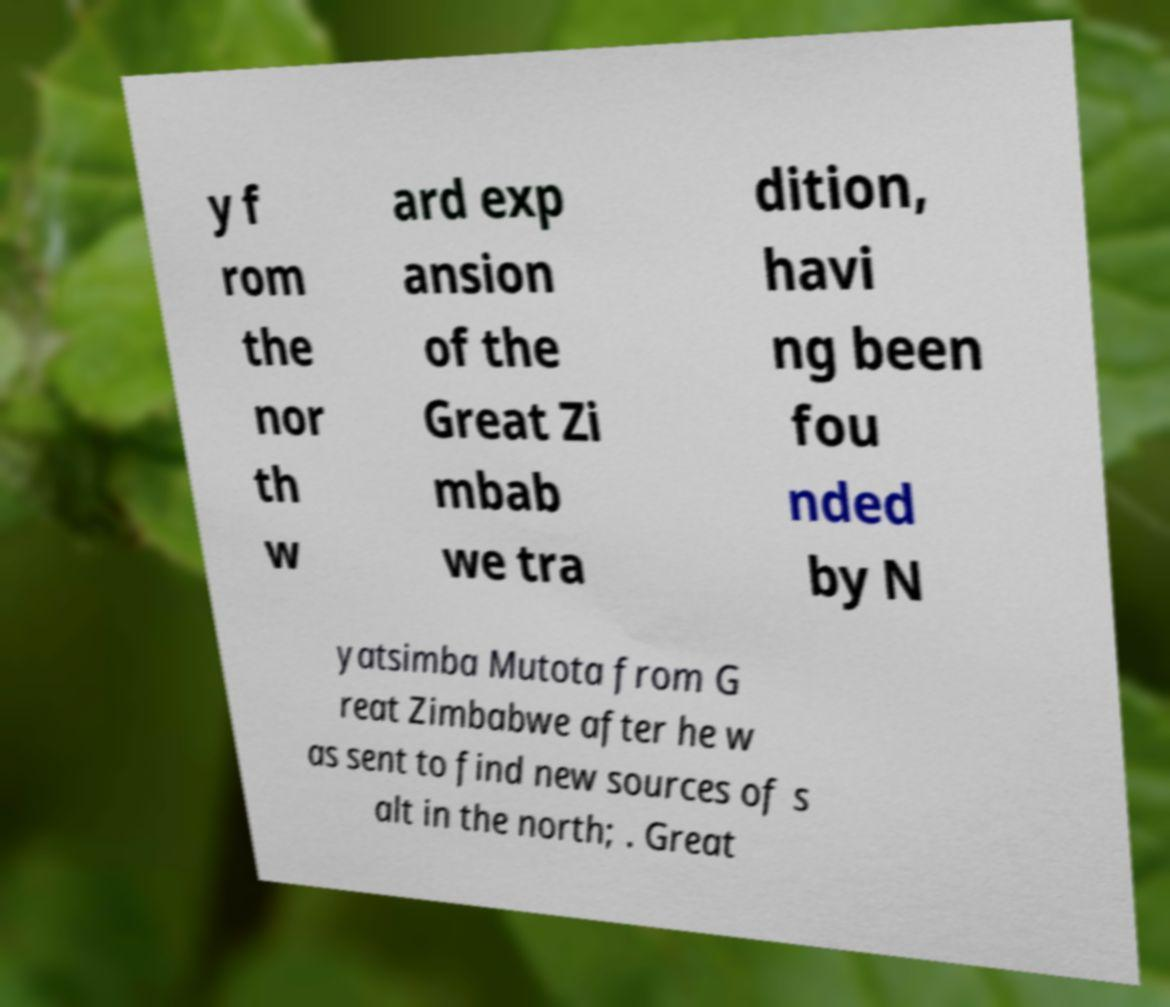For documentation purposes, I need the text within this image transcribed. Could you provide that? y f rom the nor th w ard exp ansion of the Great Zi mbab we tra dition, havi ng been fou nded by N yatsimba Mutota from G reat Zimbabwe after he w as sent to find new sources of s alt in the north; . Great 